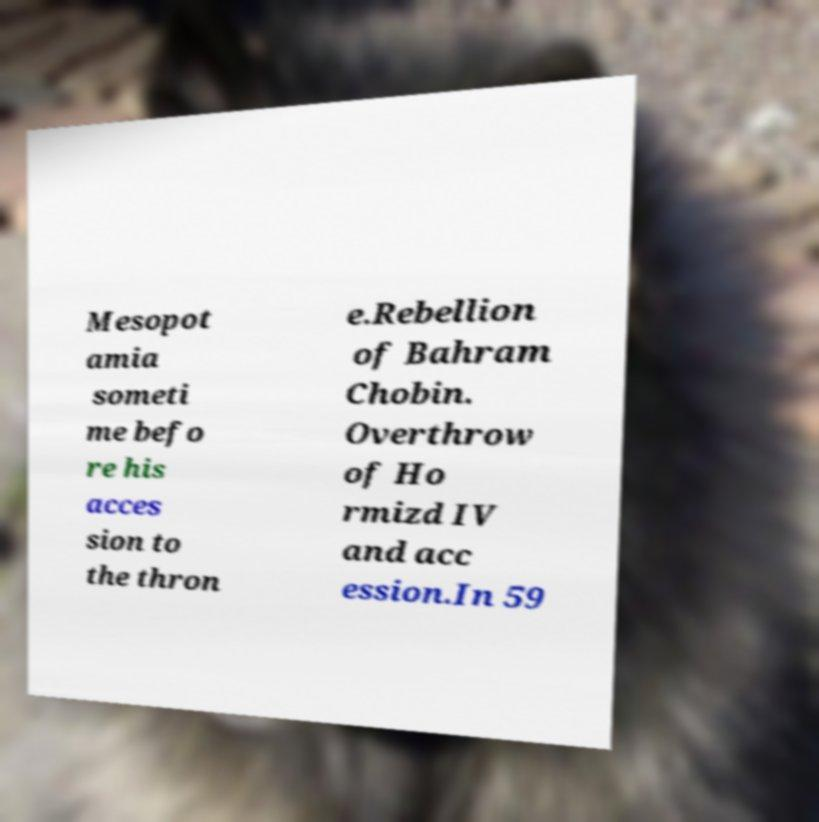Could you extract and type out the text from this image? Mesopot amia someti me befo re his acces sion to the thron e.Rebellion of Bahram Chobin. Overthrow of Ho rmizd IV and acc ession.In 59 